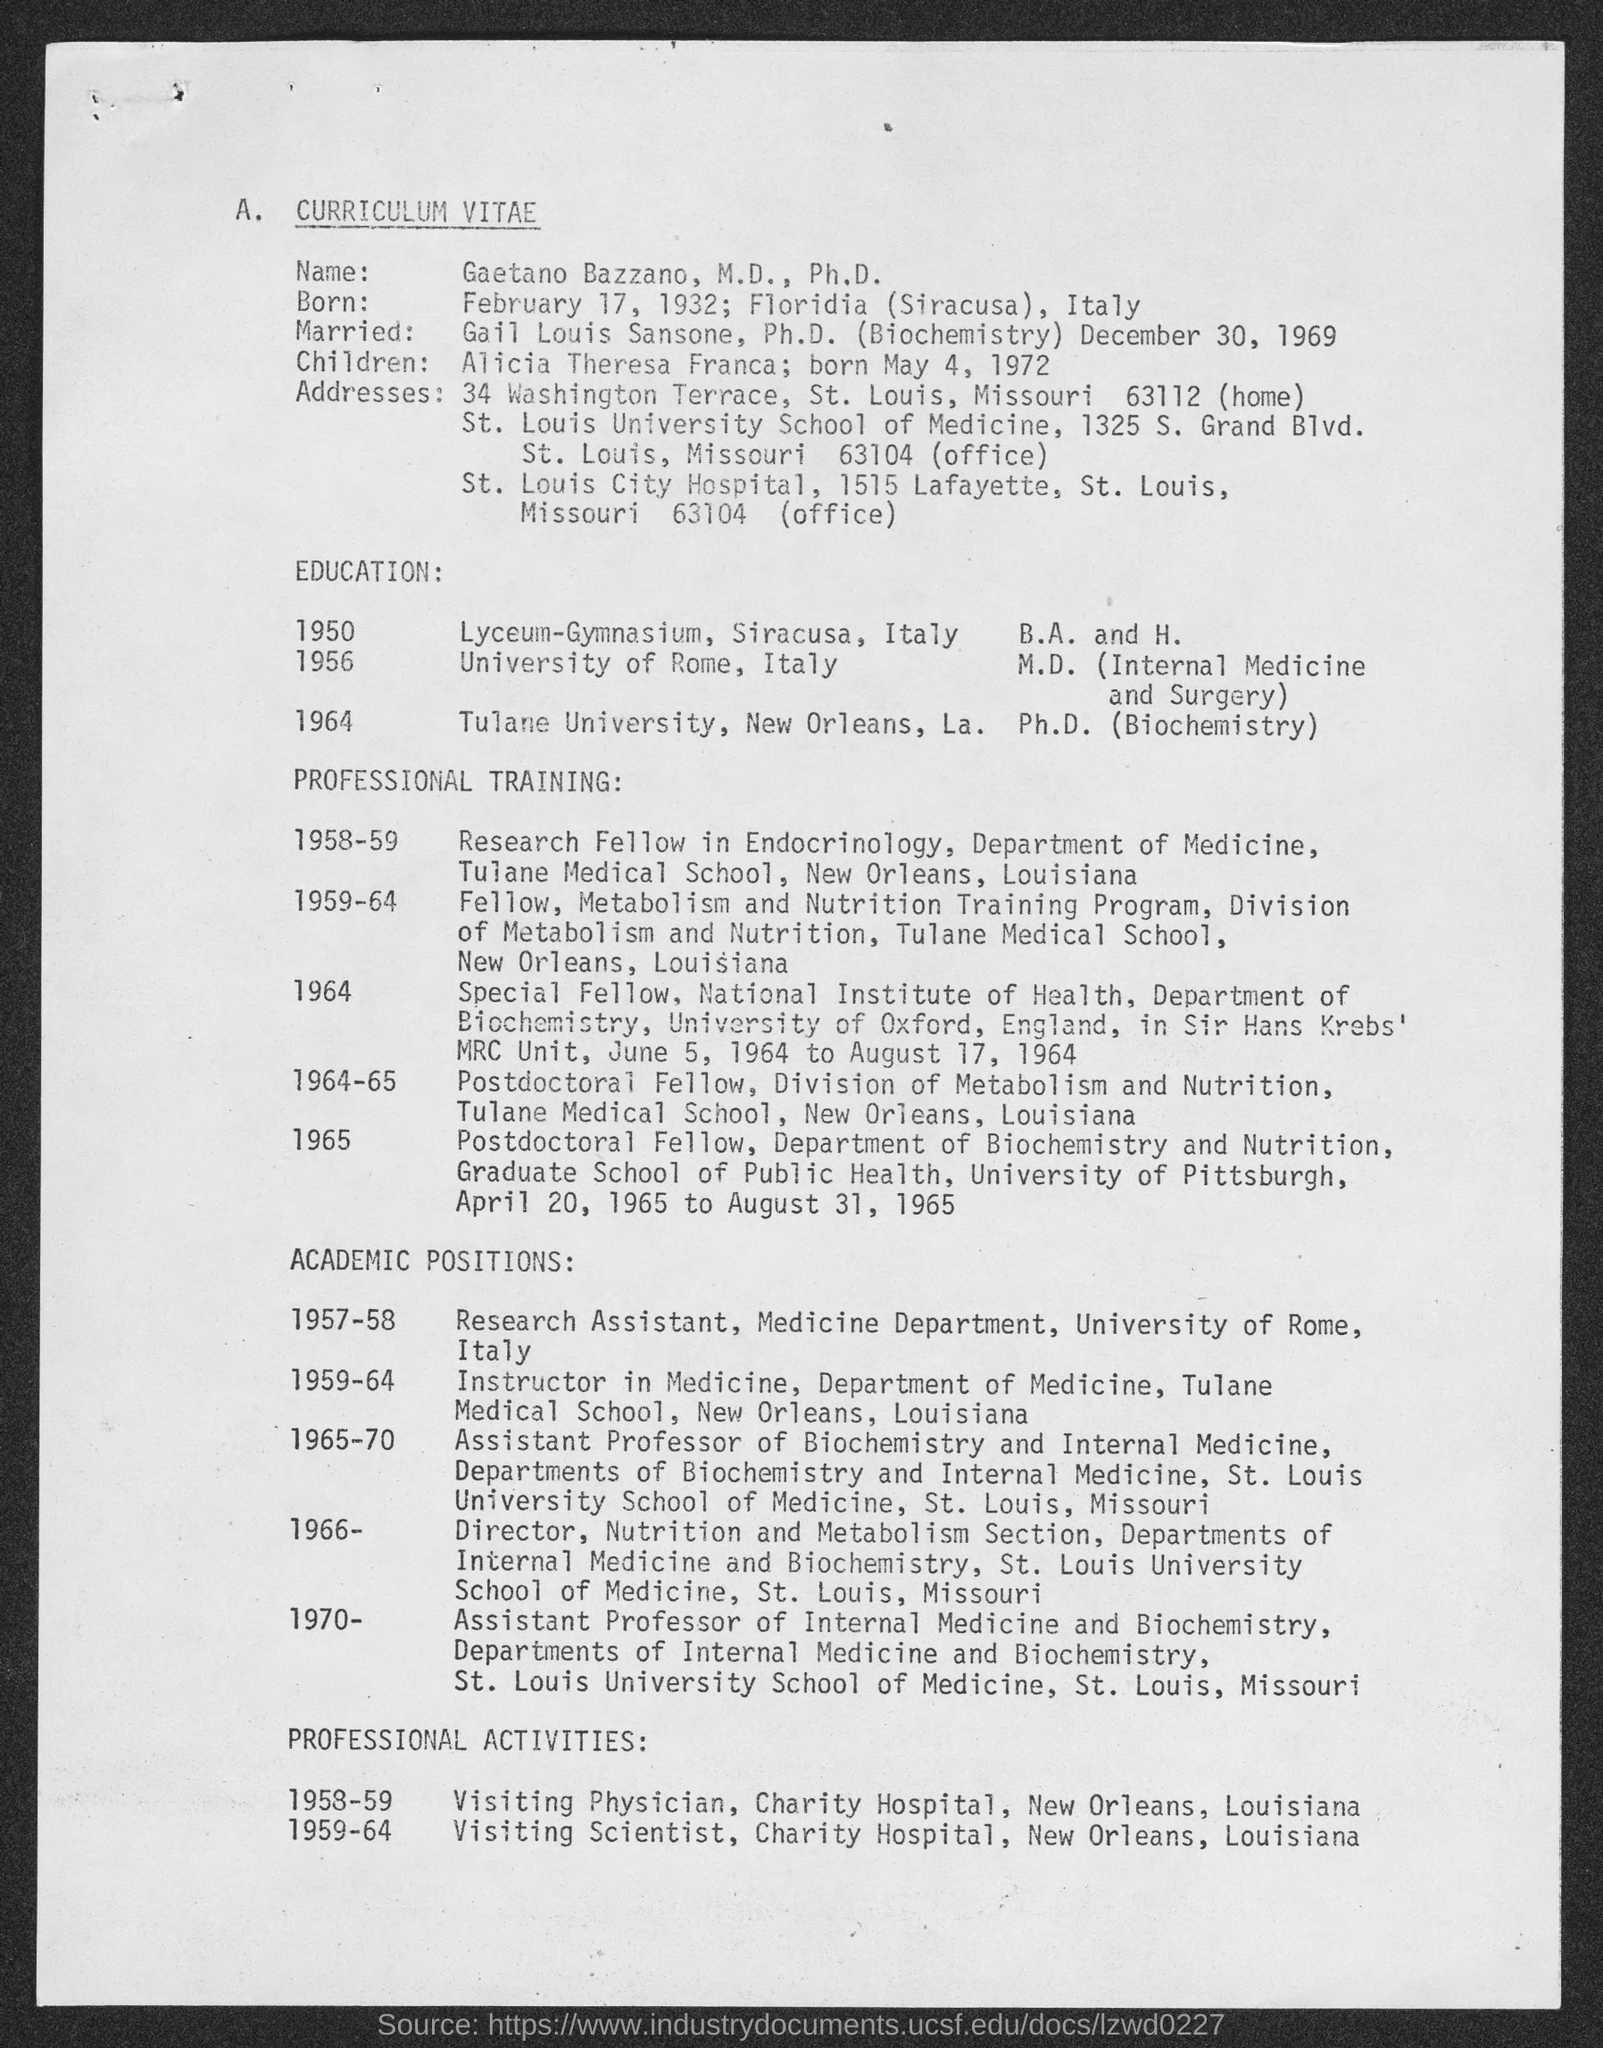Identify some key points in this picture. The title of the document is "Curriculum Vitae. 